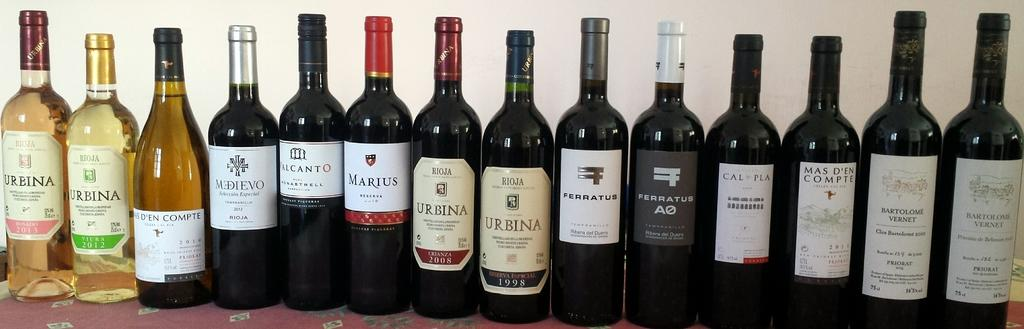Provide a one-sentence caption for the provided image. A row of wine bottles are lined in a row sitting on a table and one of the brands shown is called URBINA. 